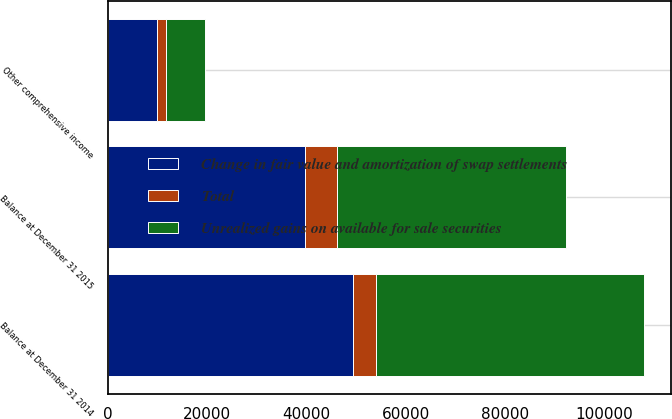<chart> <loc_0><loc_0><loc_500><loc_500><stacked_bar_chart><ecel><fcel>Balance at December 31 2014<fcel>Other comprehensive income<fcel>Balance at December 31 2015<nl><fcel>Unrealized gains on available for sale securities<fcel>53980<fcel>7893<fcel>46087<nl><fcel>Total<fcel>4624<fcel>1865<fcel>6489<nl><fcel>Change in fair value and amortization of swap settlements<fcel>49356<fcel>9758<fcel>39598<nl></chart> 